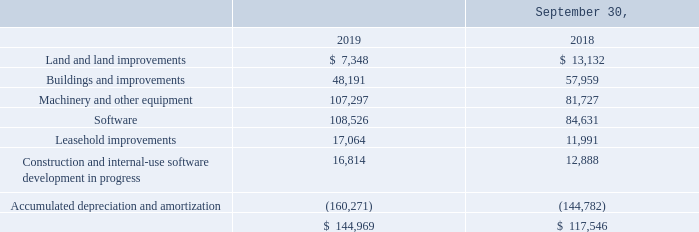NOTE 9—PROPERTY, PLANT AND EQUIPMENT
Significant components of property, plant and equipment are as follows (in thousands):
In fiscal 2019, we entered into agreements related to the construction and leasing of two buildings on our existing corporate campus in San Diego, California. Under these agreements, a financial institution will own the buildings, and we will lease the property for a term of five years upon their completion.
In the third quarter of fiscal 2019 we sold the land and buildings comprising our separate CTS campus in San Diego. We have entered into a lease with the buyer of this campus and CTS employees will continue to occupy this separate campus until the new buildings on our corporate campus are ready for occupancy in fiscal 2021. In the third quarter of fiscal 2019 we also sold land and buildings in Orlando, Florida and we are entering a lease for new space in Orlando to accommodate our employees and operations in Orlando. In connection with the sale of these real estate campuses we received total net proceeds of $44.9 million and recognized net gains on the sales totaling $32.5 million.
As a part of our efforts to upgrade our current information systems, early in fiscal 2015 we purchased new enterprise resource planning (ERP) software and began the process of designing and configuring this software and other software applications to manage our operations.
Costs incurred in the development of internal-use software and software applications, including external direct costs of materials and services and applicable compensation costs of employees devoted to specific software development, are capitalized as computer software costs. Costs incurred outside of the application development stage, or that are types of costs that do not meet the capitalization requirements, are expensed as incurred. Amounts capitalized are included in property, plant and equipment and are amortized on a straight-line basis over the estimated useful life of the software, which ranges from three to seven years. No amortization expense is recorded until the software is ready for its intended use.
Through September 30, 2019 we have incurred costs of $138.9 million related to the purchase and development of our ERP system, including $3.1 million, $22.5 million, and $40.6 million of costs incurred during fiscal years 2019, 2018 and 2017, respectively. We have capitalized $1.6 million, $7.5 million, and $16.7 million of qualifying software development costs as internal-use software development in progress during fiscal years 2019, 2018, and 2017, respectively. We have recognized expense for $1.5 million, $15.0 million, and $23.9 million of these costs in fiscal years 2019, 2018, and 2017, respectively, for costs that did not qualify for capitalization. Amounts that were expensed in connection with the development of these systems are classified within selling, general and administrative expenses in the Consolidated Statements of Operations.
Various components of our ERP system became ready for their intended use and were placed into service at various times from fiscal 2016 through fiscal 2019. As each component became ready for its intended use, the component’s costs were transferred into completed software and we began amortizing these costs over their seven-year estimated useful life using the straight-line method. We continue to capitalize costs associated with the development of other ERP components that are not yet ready for their intended use.
Our provisions for depreciation of plant and equipment and amortization of leasehold improvements and software amounted to $22.6 million, $19.5 million and $17.8 million in 2019, 2018 and 2017, respectively. Generally, we use straight-line methods for depreciable real property over estimated useful lives ranging from 15 to 39 years or for leasehold improvements, the term of the underlying lease if shorter than the estimated useful lives. We typically use accelerated methods (declining balance) for machinery and equipment and software other than our ERP system over estimated useful lives ranging from 5 to 10 years.
What do the costs incurred in the development of internal-use software and software applications include? External direct costs of materials and services and applicable compensation costs of employees devoted to specific software development. What is the amount that was capitalized in 2017 for qualifying software development costs as internal-use software development in progress? $16.7 million. In which years were the incurred costs related to the purchase and development of the ERP system recorded? 2019, 2018, 2017. In which year was the total amount of property, plant and equipment larger? 144,969>117,546
Answer: 2019. What is the change in leasehold improvements from 2018 to 2019?
Answer scale should be: thousand. 17,064-11,991
Answer: 5073. What is the percentage change in leasehold improvements from 2018 to 2019?
Answer scale should be: percent. (17,064-11,991)/11,991
Answer: 42.31. 